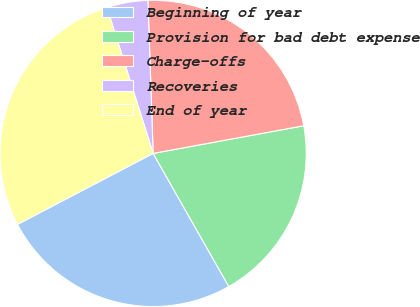Convert chart. <chart><loc_0><loc_0><loc_500><loc_500><pie_chart><fcel>Beginning of year<fcel>Provision for bad debt expense<fcel>Charge-offs<fcel>Recoveries<fcel>End of year<nl><fcel>25.55%<fcel>19.67%<fcel>22.65%<fcel>4.34%<fcel>27.79%<nl></chart> 